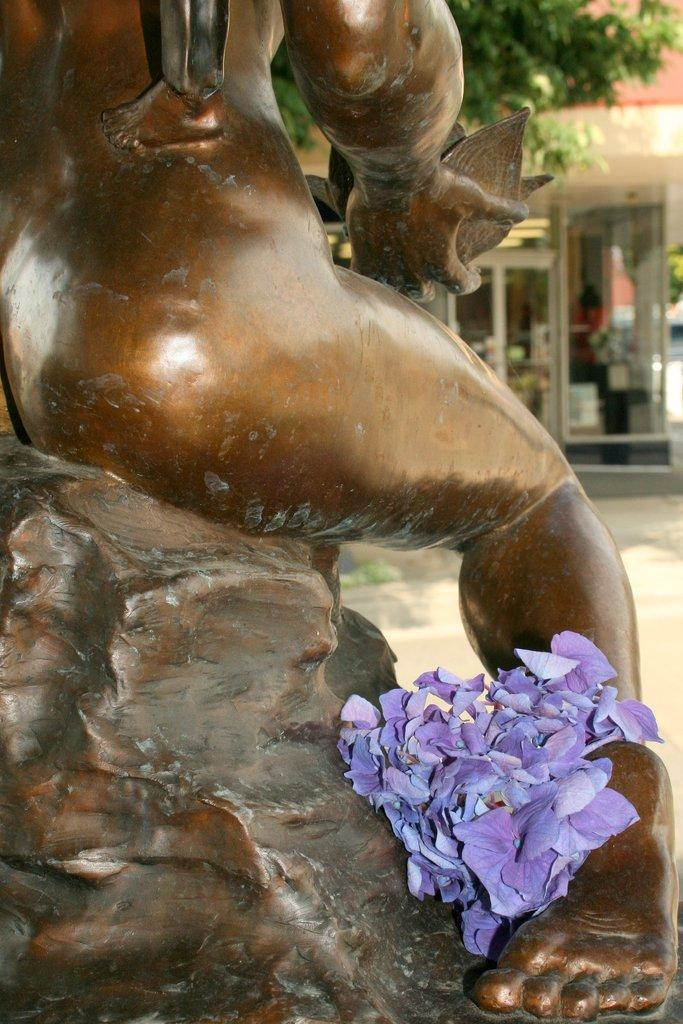What is the main subject of the image? There is a sculpture in the image. What decorative elements are present on the sculpture? There are flowers on the sculpture. What type of structure is located near the sculpture? There is a building with a glass door and window in front of the sculpture. What type of vegetation is visible in the image? There is a tree visible in the image. Where is the bag hanging in the image? There is no bag present in the image. What type of bucket can be seen near the tree in the image? There is no bucket present in the image. 